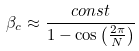Convert formula to latex. <formula><loc_0><loc_0><loc_500><loc_500>\beta _ { c } \approx \frac { c o n s t } { 1 - \cos \left ( \frac { 2 \pi } N \right ) }</formula> 